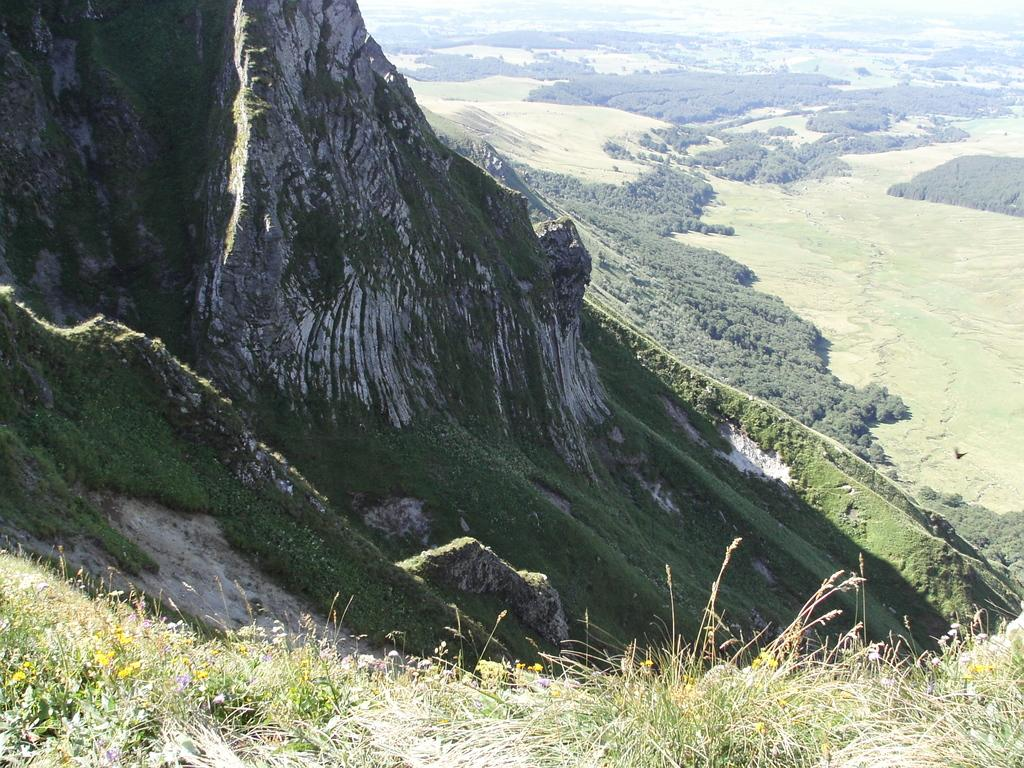What type of natural formation can be seen in the image? There are mountains in the image. What can be observed around the mountains? There is a lot of greenery surrounding the mountains. Where is the nest of rabbits located in the image? There is no nest or rabbits present in the image; it only features mountains and greenery. What type of soda can be seen in the image? There is no soda present in the image. 